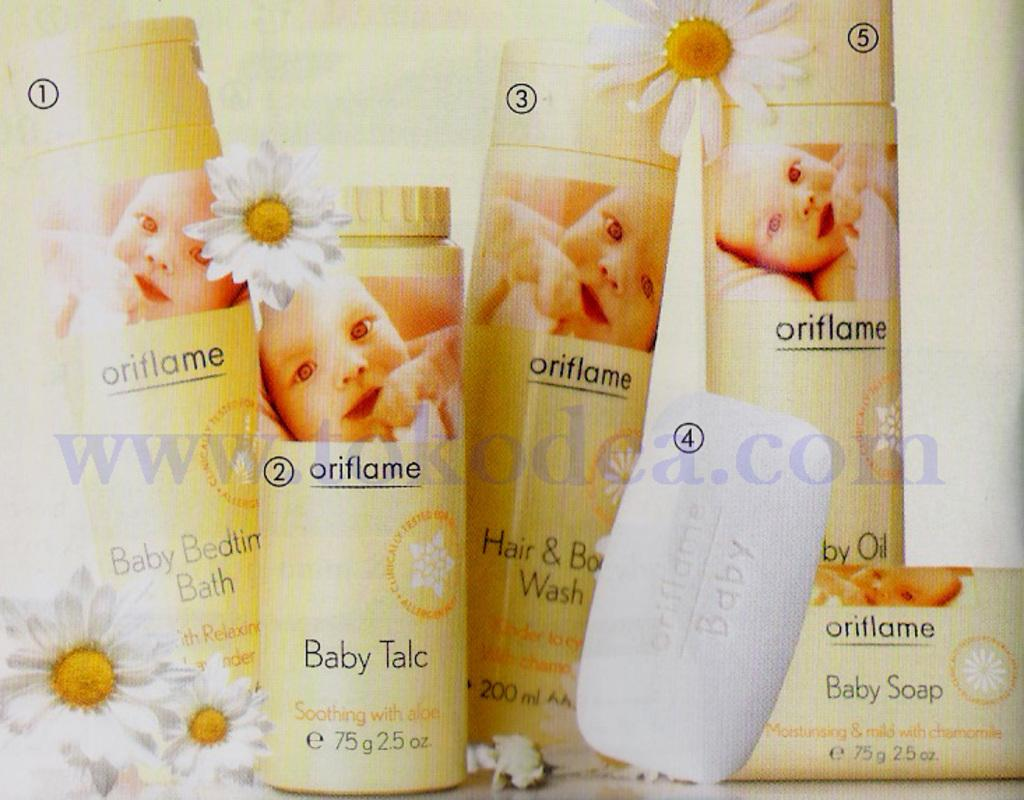What type of objects can be seen in the image? There are bottles, soap, and flowers in the image. What is the format of the image? The image is a poster. Is there any text or symbol in the middle of the image? Yes, there is a watermark in the middle of the image. How are the objects in the image identified? The objects in the image are labeled with numbers. What is the price of the camp shown in the image? There is no camp present in the image, and therefore no price can be determined. Can you see any monkeys interacting with the flowers in the image? There are no monkeys present in the image; it features bottles, soap, and flowers. 